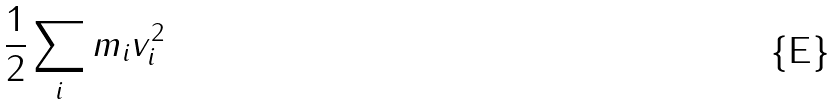Convert formula to latex. <formula><loc_0><loc_0><loc_500><loc_500>\frac { 1 } { 2 } \sum _ { i } m _ { i } v _ { i } ^ { 2 }</formula> 